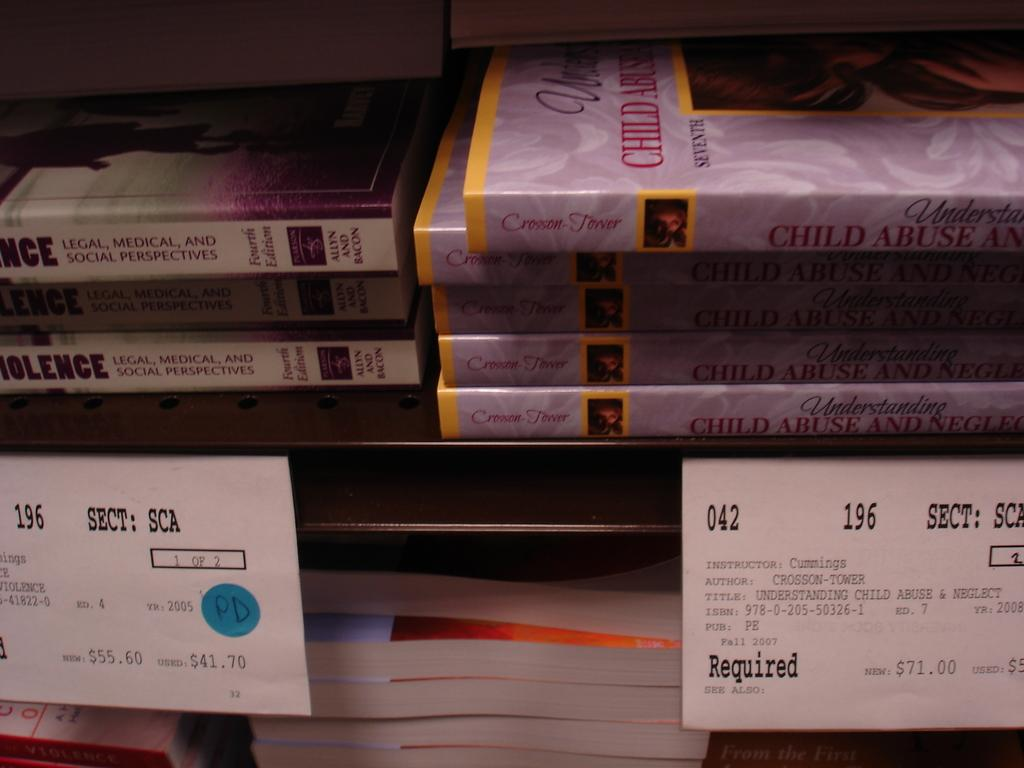<image>
Give a short and clear explanation of the subsequent image. Dvds about child abuse are stacked on a shelf. 